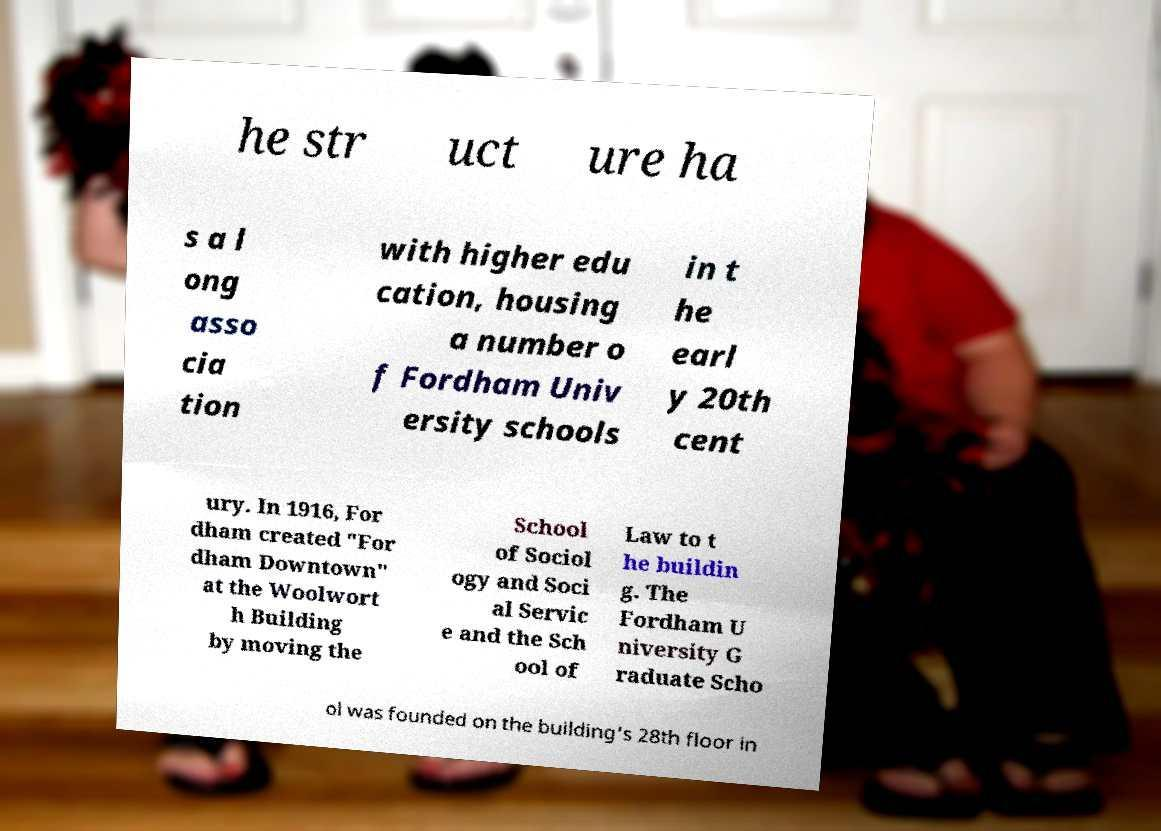For documentation purposes, I need the text within this image transcribed. Could you provide that? he str uct ure ha s a l ong asso cia tion with higher edu cation, housing a number o f Fordham Univ ersity schools in t he earl y 20th cent ury. In 1916, For dham created "For dham Downtown" at the Woolwort h Building by moving the School of Sociol ogy and Soci al Servic e and the Sch ool of Law to t he buildin g. The Fordham U niversity G raduate Scho ol was founded on the building's 28th floor in 